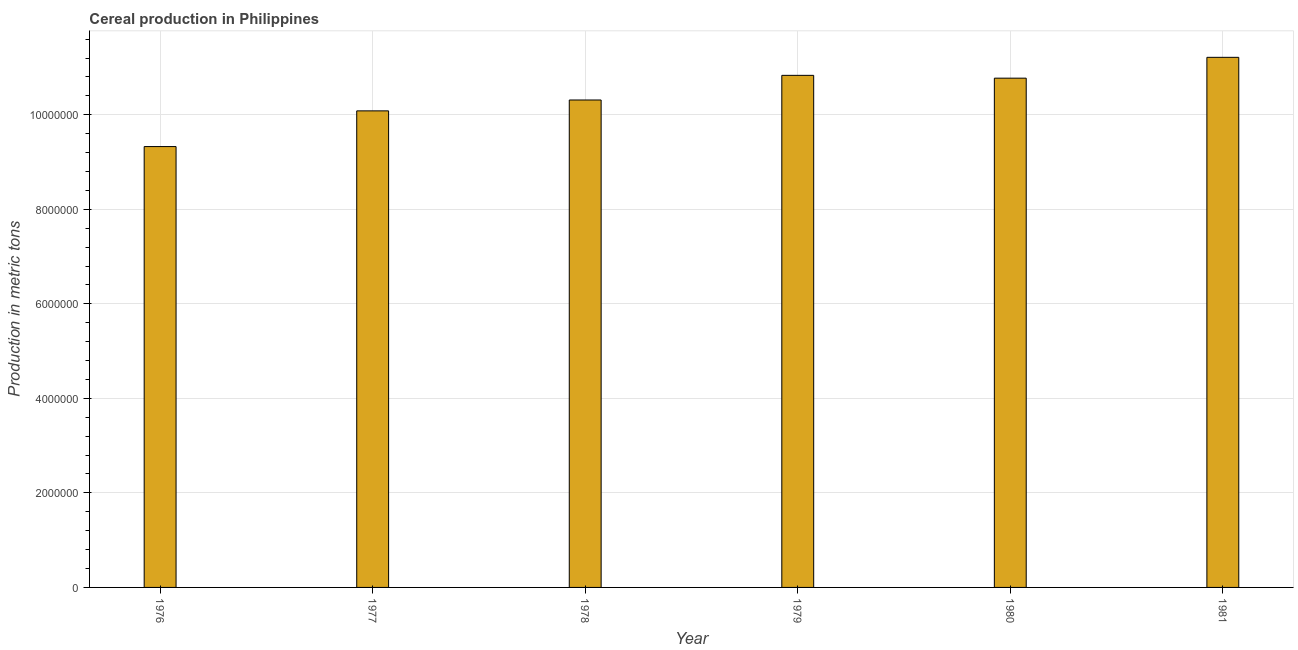Does the graph contain grids?
Provide a succinct answer. Yes. What is the title of the graph?
Your response must be concise. Cereal production in Philippines. What is the label or title of the Y-axis?
Keep it short and to the point. Production in metric tons. What is the cereal production in 1981?
Your answer should be very brief. 1.12e+07. Across all years, what is the maximum cereal production?
Make the answer very short. 1.12e+07. Across all years, what is the minimum cereal production?
Provide a short and direct response. 9.33e+06. In which year was the cereal production maximum?
Keep it short and to the point. 1981. In which year was the cereal production minimum?
Give a very brief answer. 1976. What is the sum of the cereal production?
Provide a short and direct response. 6.25e+07. What is the difference between the cereal production in 1977 and 1981?
Provide a short and direct response. -1.13e+06. What is the average cereal production per year?
Give a very brief answer. 1.04e+07. What is the median cereal production?
Provide a short and direct response. 1.05e+07. In how many years, is the cereal production greater than 4000000 metric tons?
Keep it short and to the point. 6. Do a majority of the years between 1976 and 1981 (inclusive) have cereal production greater than 6000000 metric tons?
Your response must be concise. Yes. What is the ratio of the cereal production in 1977 to that in 1981?
Your answer should be very brief. 0.9. Is the difference between the cereal production in 1976 and 1979 greater than the difference between any two years?
Provide a succinct answer. No. What is the difference between the highest and the second highest cereal production?
Give a very brief answer. 3.81e+05. Is the sum of the cereal production in 1977 and 1981 greater than the maximum cereal production across all years?
Give a very brief answer. Yes. What is the difference between the highest and the lowest cereal production?
Give a very brief answer. 1.89e+06. Are all the bars in the graph horizontal?
Provide a short and direct response. No. How many years are there in the graph?
Your answer should be very brief. 6. What is the difference between two consecutive major ticks on the Y-axis?
Offer a terse response. 2.00e+06. What is the Production in metric tons in 1976?
Provide a succinct answer. 9.33e+06. What is the Production in metric tons in 1977?
Offer a very short reply. 1.01e+07. What is the Production in metric tons of 1978?
Provide a short and direct response. 1.03e+07. What is the Production in metric tons of 1979?
Give a very brief answer. 1.08e+07. What is the Production in metric tons of 1980?
Your response must be concise. 1.08e+07. What is the Production in metric tons in 1981?
Ensure brevity in your answer.  1.12e+07. What is the difference between the Production in metric tons in 1976 and 1977?
Provide a short and direct response. -7.56e+05. What is the difference between the Production in metric tons in 1976 and 1978?
Your answer should be compact. -9.86e+05. What is the difference between the Production in metric tons in 1976 and 1979?
Provide a succinct answer. -1.51e+06. What is the difference between the Production in metric tons in 1976 and 1980?
Keep it short and to the point. -1.45e+06. What is the difference between the Production in metric tons in 1976 and 1981?
Give a very brief answer. -1.89e+06. What is the difference between the Production in metric tons in 1977 and 1978?
Your response must be concise. -2.30e+05. What is the difference between the Production in metric tons in 1977 and 1979?
Offer a very short reply. -7.51e+05. What is the difference between the Production in metric tons in 1977 and 1980?
Your answer should be compact. -6.92e+05. What is the difference between the Production in metric tons in 1977 and 1981?
Ensure brevity in your answer.  -1.13e+06. What is the difference between the Production in metric tons in 1978 and 1979?
Make the answer very short. -5.21e+05. What is the difference between the Production in metric tons in 1978 and 1980?
Offer a terse response. -4.62e+05. What is the difference between the Production in metric tons in 1978 and 1981?
Keep it short and to the point. -9.03e+05. What is the difference between the Production in metric tons in 1979 and 1980?
Give a very brief answer. 5.94e+04. What is the difference between the Production in metric tons in 1979 and 1981?
Your response must be concise. -3.81e+05. What is the difference between the Production in metric tons in 1980 and 1981?
Keep it short and to the point. -4.41e+05. What is the ratio of the Production in metric tons in 1976 to that in 1977?
Your response must be concise. 0.93. What is the ratio of the Production in metric tons in 1976 to that in 1978?
Offer a terse response. 0.9. What is the ratio of the Production in metric tons in 1976 to that in 1979?
Offer a terse response. 0.86. What is the ratio of the Production in metric tons in 1976 to that in 1980?
Offer a terse response. 0.87. What is the ratio of the Production in metric tons in 1976 to that in 1981?
Provide a succinct answer. 0.83. What is the ratio of the Production in metric tons in 1977 to that in 1979?
Ensure brevity in your answer.  0.93. What is the ratio of the Production in metric tons in 1977 to that in 1980?
Give a very brief answer. 0.94. What is the ratio of the Production in metric tons in 1977 to that in 1981?
Keep it short and to the point. 0.9. What is the ratio of the Production in metric tons in 1978 to that in 1979?
Provide a short and direct response. 0.95. What is the ratio of the Production in metric tons in 1979 to that in 1980?
Give a very brief answer. 1.01. What is the ratio of the Production in metric tons in 1979 to that in 1981?
Your response must be concise. 0.97. What is the ratio of the Production in metric tons in 1980 to that in 1981?
Offer a very short reply. 0.96. 